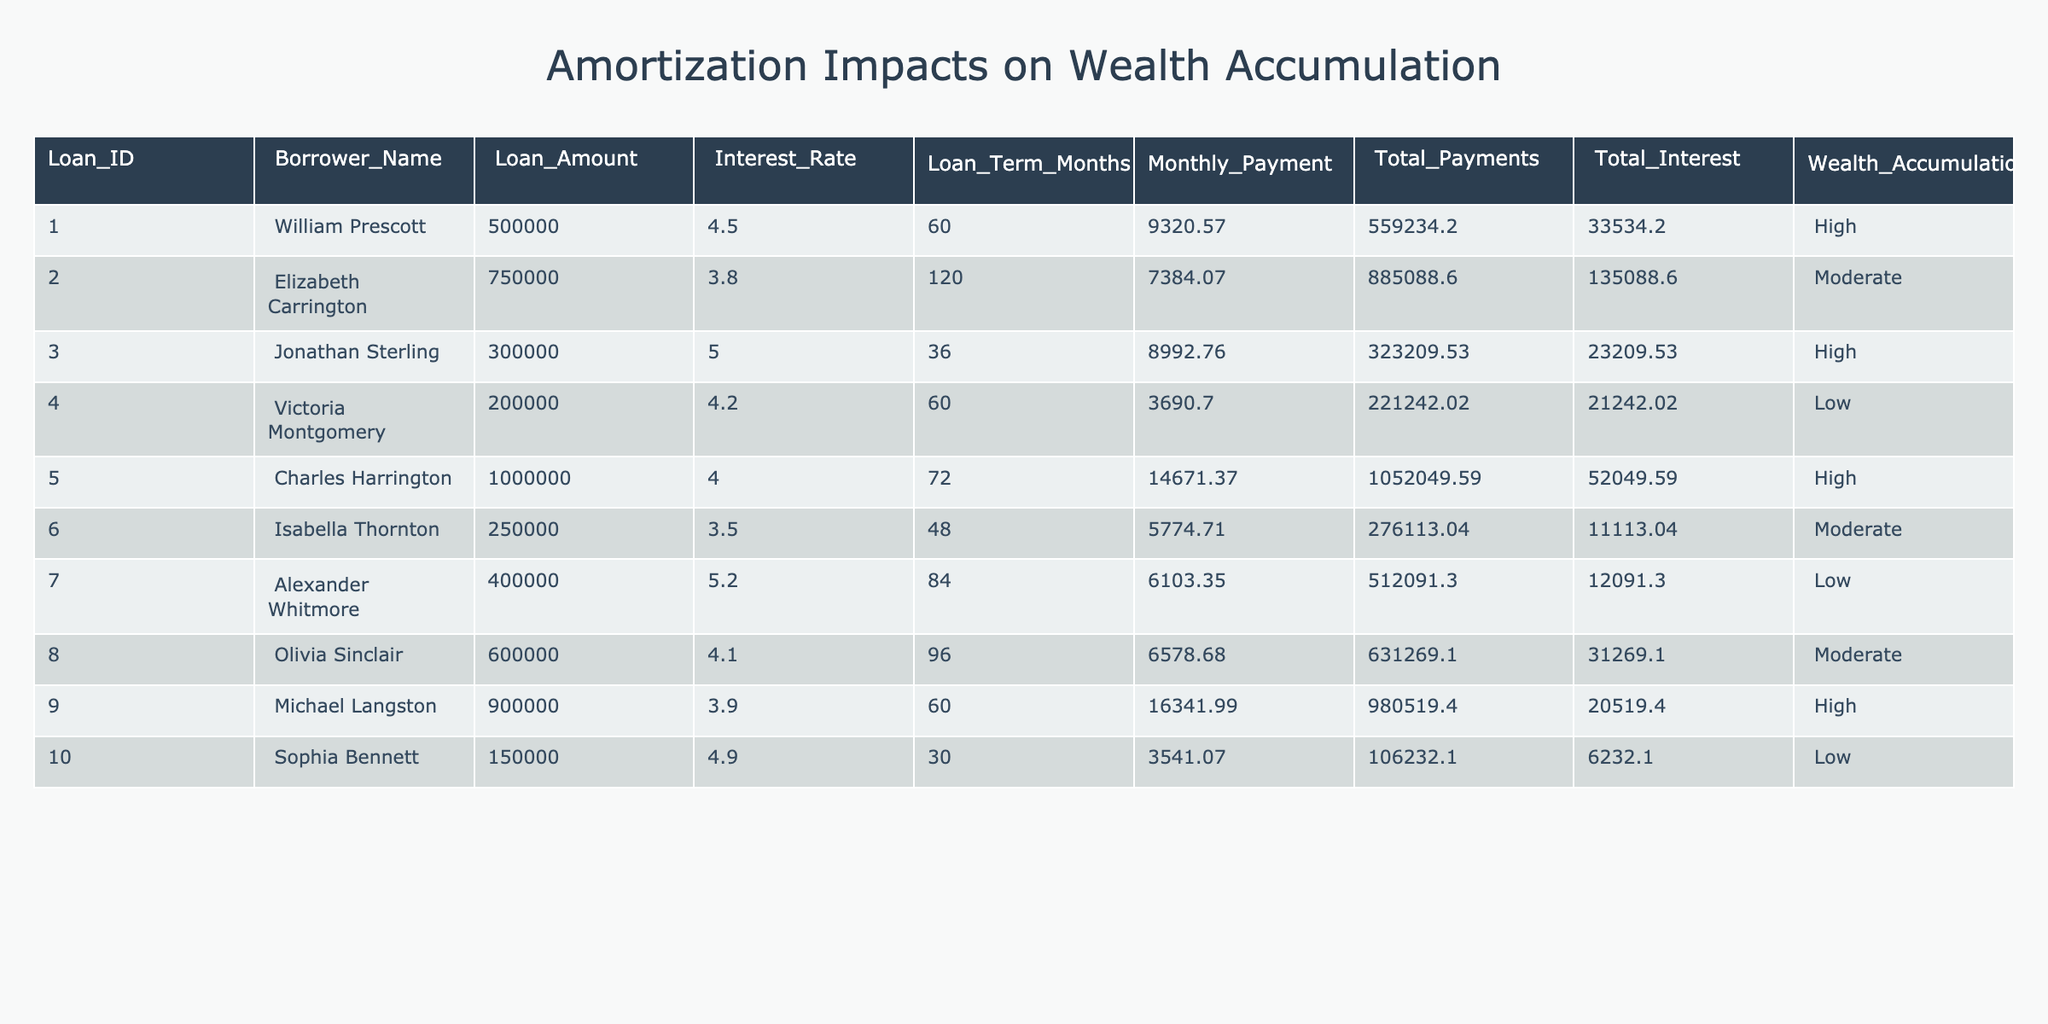What is the total loan amount for William Prescott? The table lists the loan amount for each borrower. For William Prescott, the loan amount is directly provided as 500,000.
Answer: 500000 What is the monthly payment for the loan taken by Elizabeth Carrington? The monthly payment for Elizabeth Carrington is listed in the table under "Monthly Payment," which shows the amount is 7,384.07.
Answer: 7384.07 Are there any borrowers with a wealth accumulation impact categorized as low? By checking the "Wealth Accumulation Impact" column in the table, I see that Victoria Montgomery and Alexander Whitmore are both categorized with a low impact. Therefore, the answer is yes.
Answer: Yes What is the difference between the total interest paid by Charles Harrington and Jonathan Sterling? Looking at the "Total Interest" values for both borrowers, Charles Harrington paid 52,049.59 and Jonathan Sterling paid 23,209.53. The difference is calculated as 52,049.59 - 23,209.53, which equals 28,840.06.
Answer: 28840.06 How many borrowers have a loan term greater than 60 months? Analyzing the "Loan Term Months" column, I find that Elizabeth Carrington (120 months), Charles Harrington (72 months), Olivia Sinclair (96 months), and Alexander Whitmore (84 months) have terms greater than 60. There are a total of 4 borrowers.
Answer: 4 Which borrower had the highest total payments? To find the borrower with the highest total payments, I will compare the "Total Payments" for each individual. Charles Harrington has the highest total payments at 1,052,049.59.
Answer: Charles Harrington What is the average interest rate for loans that have a high wealth accumulation impact? First, I identify the relevant borrowers who have high impact: William Prescott, Jonathan Sterling, Michael Langston, and Charles Harrington. Their interest rates are 4.5, 5.0, 3.9, and 4.0 respectively. The average interest rate is calculated as (4.5 + 5.0 + 3.9 + 4.0) / 4 = 4.35.
Answer: 4.35 Is there any borrower with a loan amount of exactly 200,000? By scanning the "Loan Amount" column, I see that Victoria Montgomery has a loan amount of 200,000. Hence, the answer is yes.
Answer: Yes What is the total of all monthly payments listed for the borrowers in the table? I add the monthly payments for each borrower: 9,320.57 + 7,384.07 + 8,992.76 + 3,690.70 + 14,671.37 + 5,774.71 + 6,103.35 + 6,578.68 + 16,341.99 + 3,541.07. The total is 81,550.54.
Answer: 81550.54 